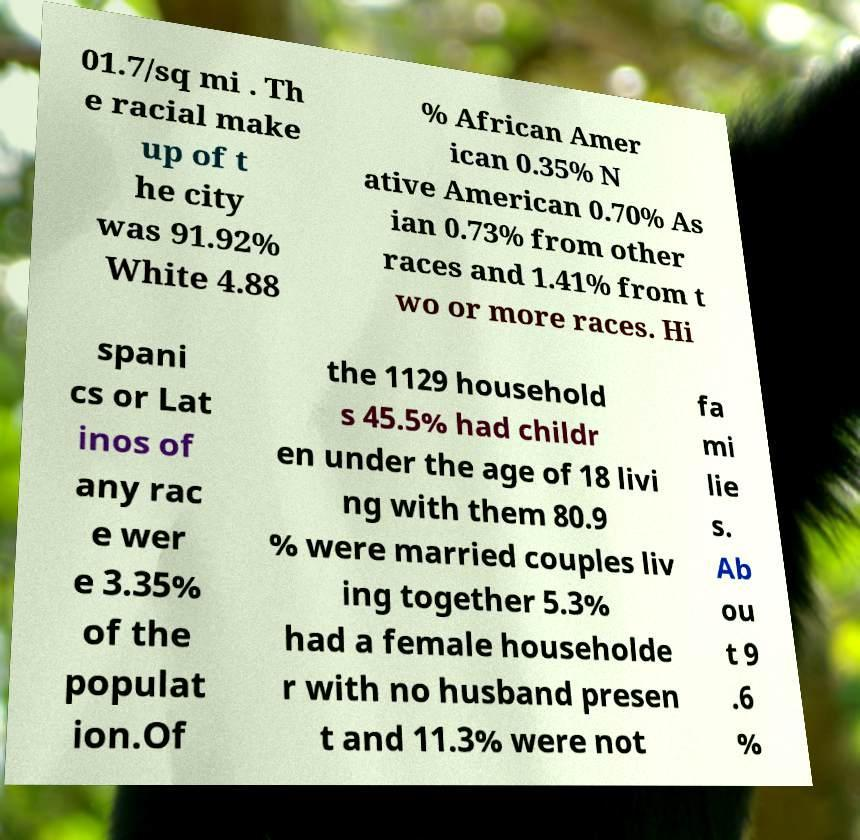Can you read and provide the text displayed in the image?This photo seems to have some interesting text. Can you extract and type it out for me? 01.7/sq mi . Th e racial make up of t he city was 91.92% White 4.88 % African Amer ican 0.35% N ative American 0.70% As ian 0.73% from other races and 1.41% from t wo or more races. Hi spani cs or Lat inos of any rac e wer e 3.35% of the populat ion.Of the 1129 household s 45.5% had childr en under the age of 18 livi ng with them 80.9 % were married couples liv ing together 5.3% had a female householde r with no husband presen t and 11.3% were not fa mi lie s. Ab ou t 9 .6 % 